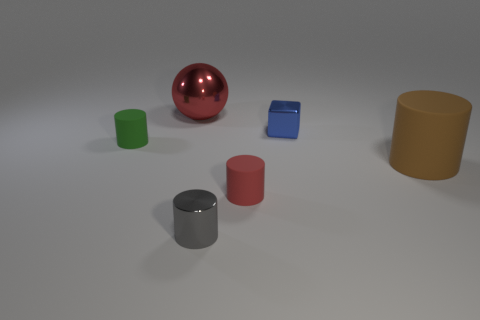How many other things are there of the same color as the metal ball?
Make the answer very short. 1. There is a shiny sphere; are there any metal objects right of it?
Your response must be concise. Yes. What is the color of the tiny metal object in front of the small metal object behind the small cylinder on the left side of the large red metal sphere?
Give a very brief answer. Gray. What number of matte things are to the right of the tiny blue metallic block and in front of the big brown object?
Give a very brief answer. 0. What number of balls are either blue metallic things or red metallic objects?
Make the answer very short. 1. Is there a gray shiny object?
Your answer should be compact. Yes. There is a green object that is the same size as the cube; what material is it?
Offer a very short reply. Rubber. Is the shape of the small shiny object behind the green cylinder the same as  the big red metal object?
Give a very brief answer. No. What number of things are either green rubber things that are to the left of the brown thing or rubber cylinders?
Your answer should be compact. 3. What is the shape of the blue thing that is the same size as the gray thing?
Offer a terse response. Cube. 